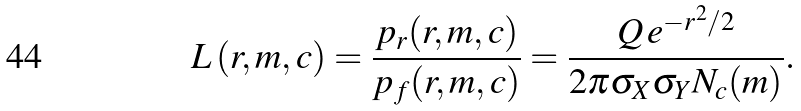<formula> <loc_0><loc_0><loc_500><loc_500>L \, ( r , m , c ) = \frac { p _ { r } ( r , m , c ) } { p _ { f } ( r , m , c ) } = \frac { Q \, e ^ { - r ^ { 2 } / 2 } } { 2 \pi \sigma _ { X } \sigma _ { Y } N _ { c } ( m ) } .</formula> 